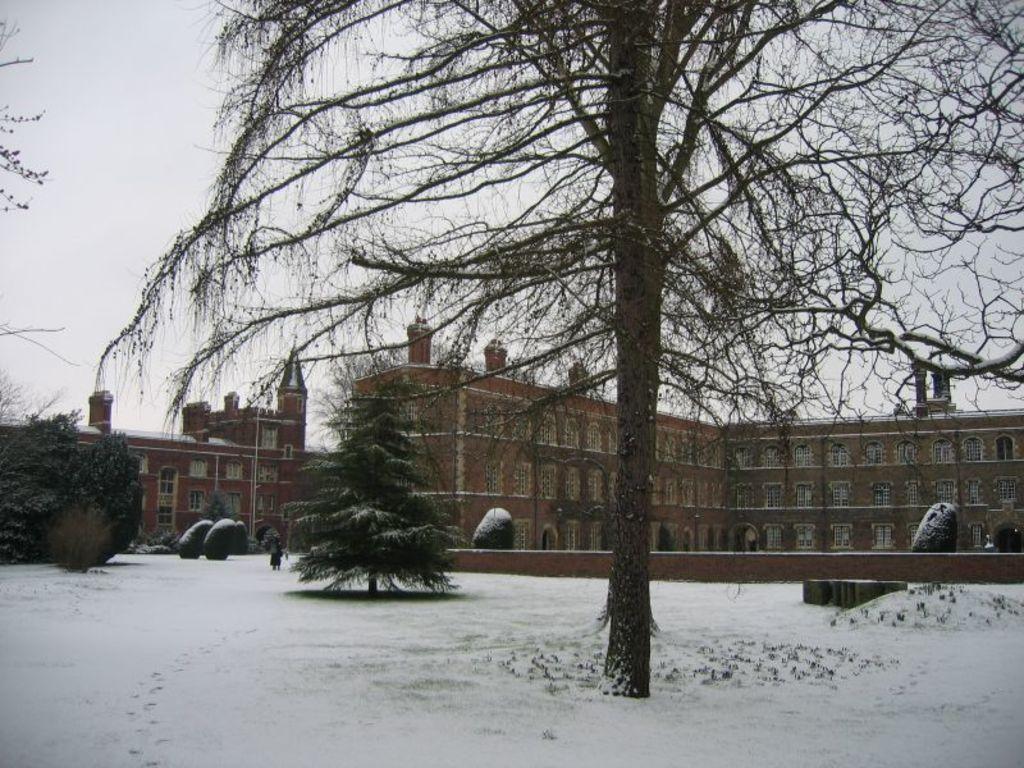Can you describe this image briefly? In this image I can see some snow on the ground, few trees, a person standing on the snow and few buildings which are brown and cream in color. In the background I can see the sky. 